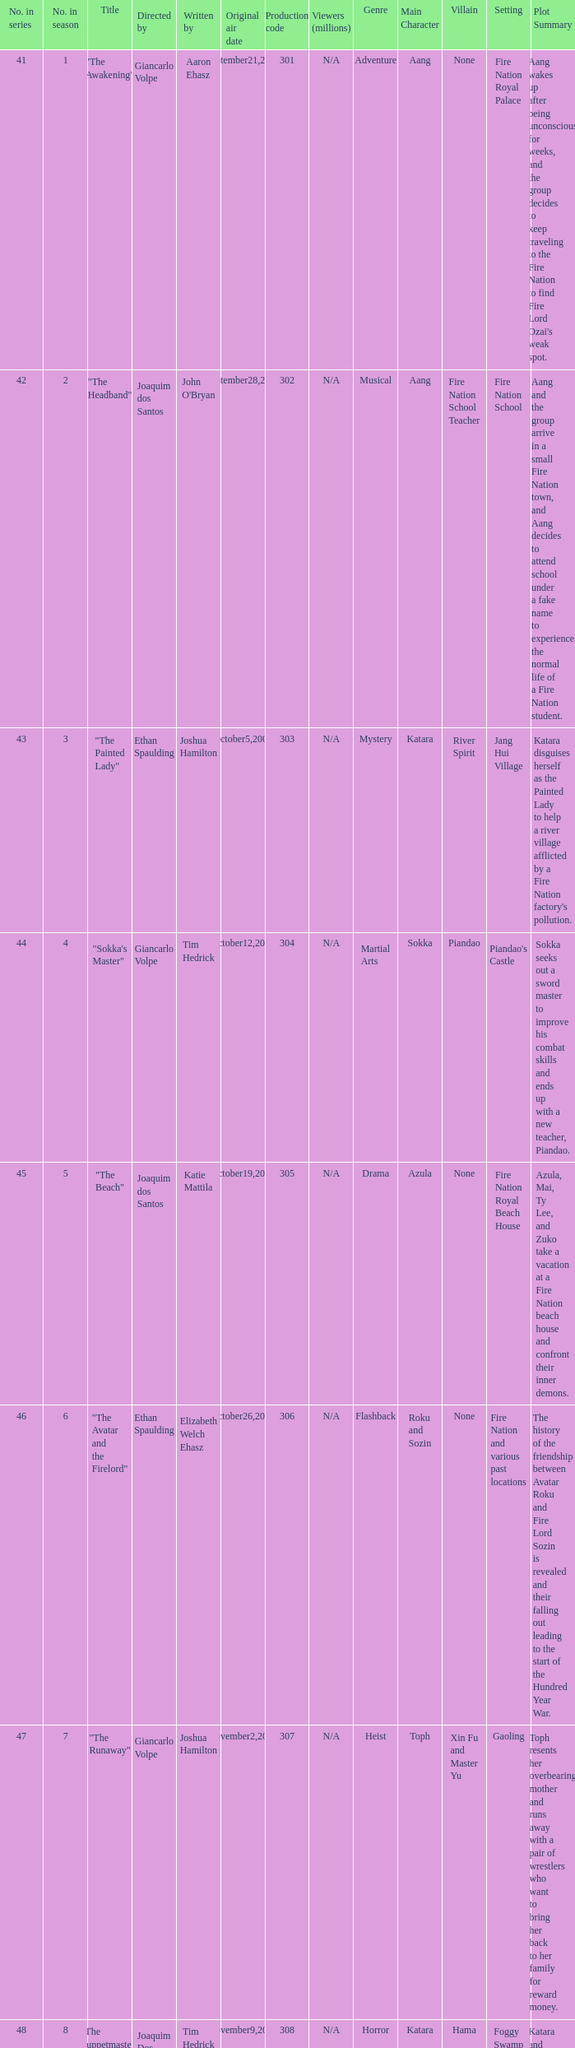How many viewers in millions for episode "sokka's master"? N/A. 